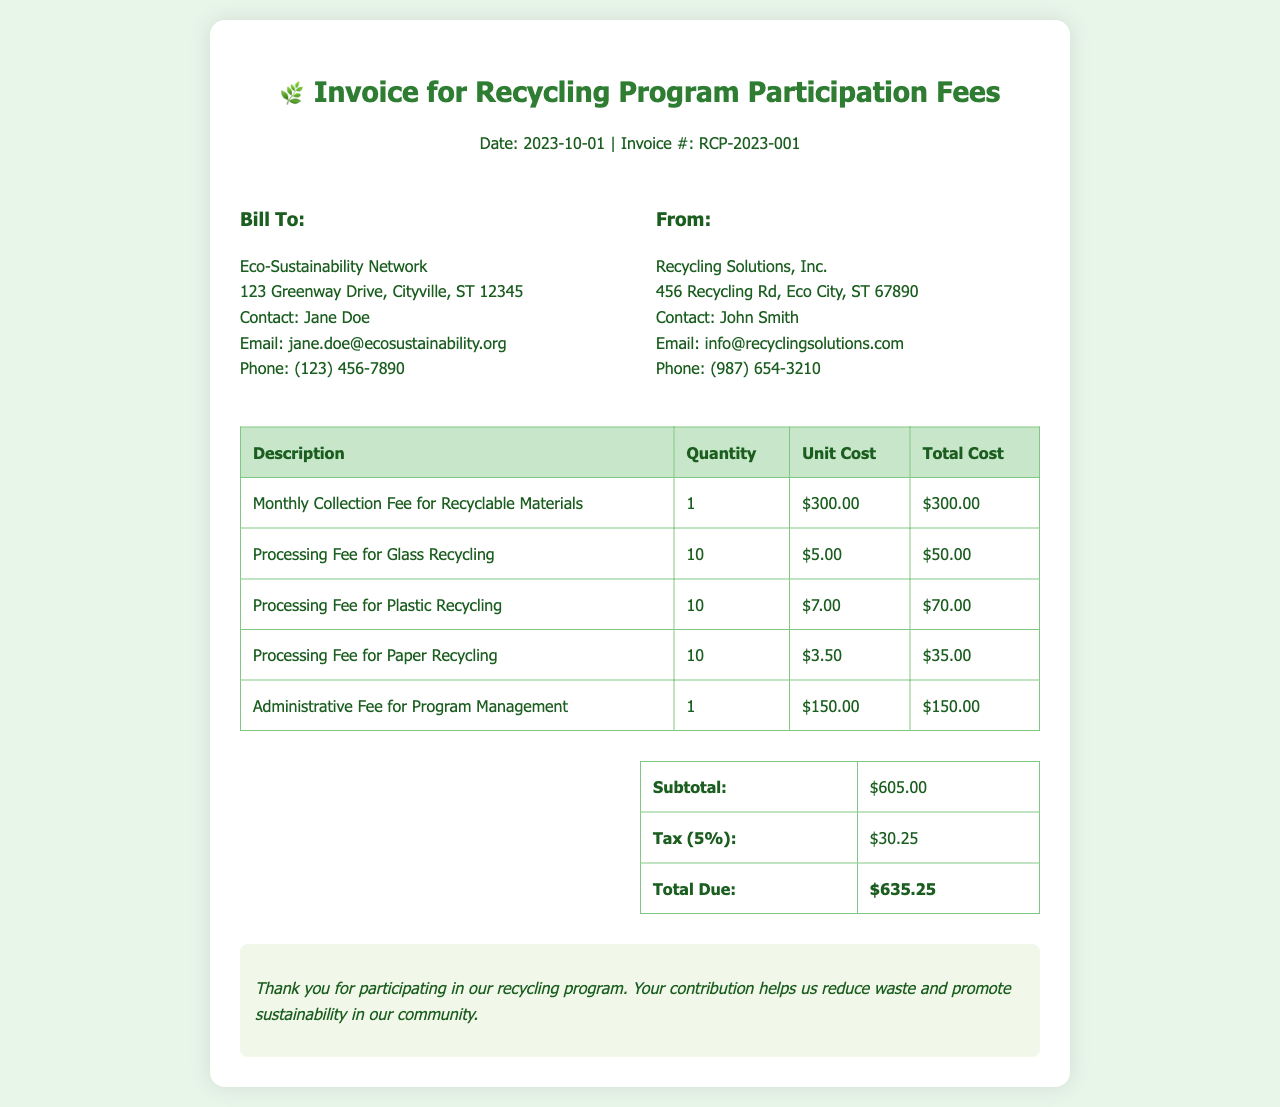What is the invoice number? The invoice number is a specific identifier for the invoice listed at the top of the document.
Answer: RCP-2023-001 Who is the contact person for the Eco-Sustainability Network? The contact person is the individual listed under the "Bill To" section of the invoice.
Answer: Jane Doe What is the total due for this invoice? The total due is the final amount that needs to be paid, calculated from the subtotal and tax.
Answer: $635.25 How much is the processing fee for glass recycling? The processing fee for glass recycling is detailed in the table of costs on the invoice.
Answer: $50.00 What is the subtotal amount before tax? The subtotal is the sum of all the costs listed before adding tax, which is shown in the summary section.
Answer: $605.00 What is the percentage of tax applied to the invoice? The tax percentage is clearly indicated in the summary section of the invoice.
Answer: 5% How many processing fees are listed in the invoice? The processing fees are detailed in the table and refer to the separate categories for materials.
Answer: 3 What does the administrative fee cover? The administrative fee represents the cost associated with the management of the recycling program, as mentioned in the invoice.
Answer: Program Management 